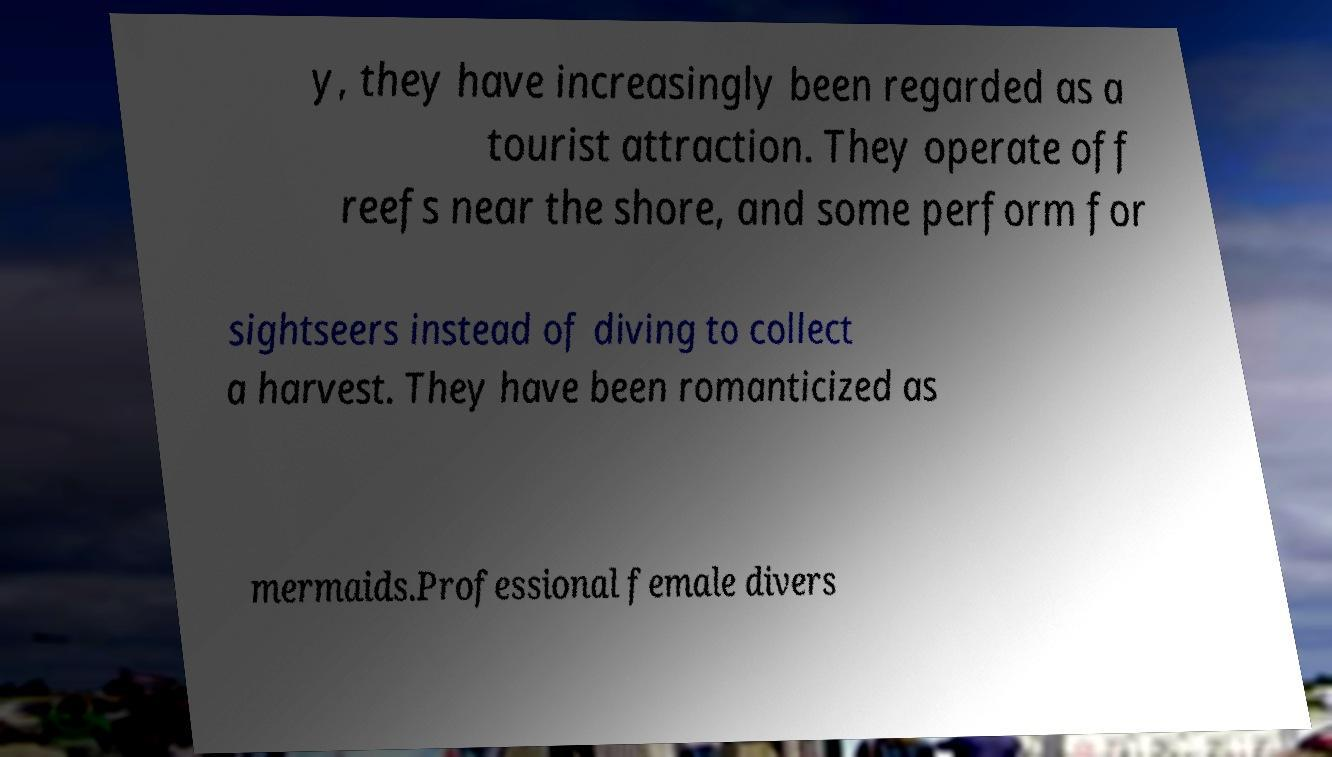There's text embedded in this image that I need extracted. Can you transcribe it verbatim? y, they have increasingly been regarded as a tourist attraction. They operate off reefs near the shore, and some perform for sightseers instead of diving to collect a harvest. They have been romanticized as mermaids.Professional female divers 